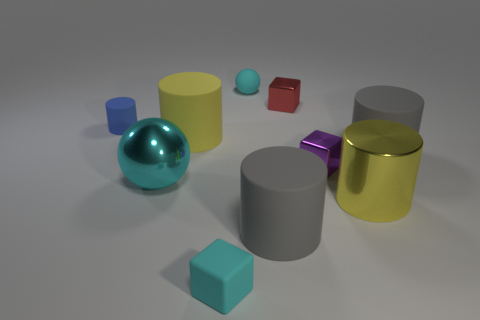Compare the two cubes in the image. The two cubes in the image differ in size and color. The cube on the left is larger and has a blue color, while the smaller cube on the right is red and appears to be about half the size of the blue one. 